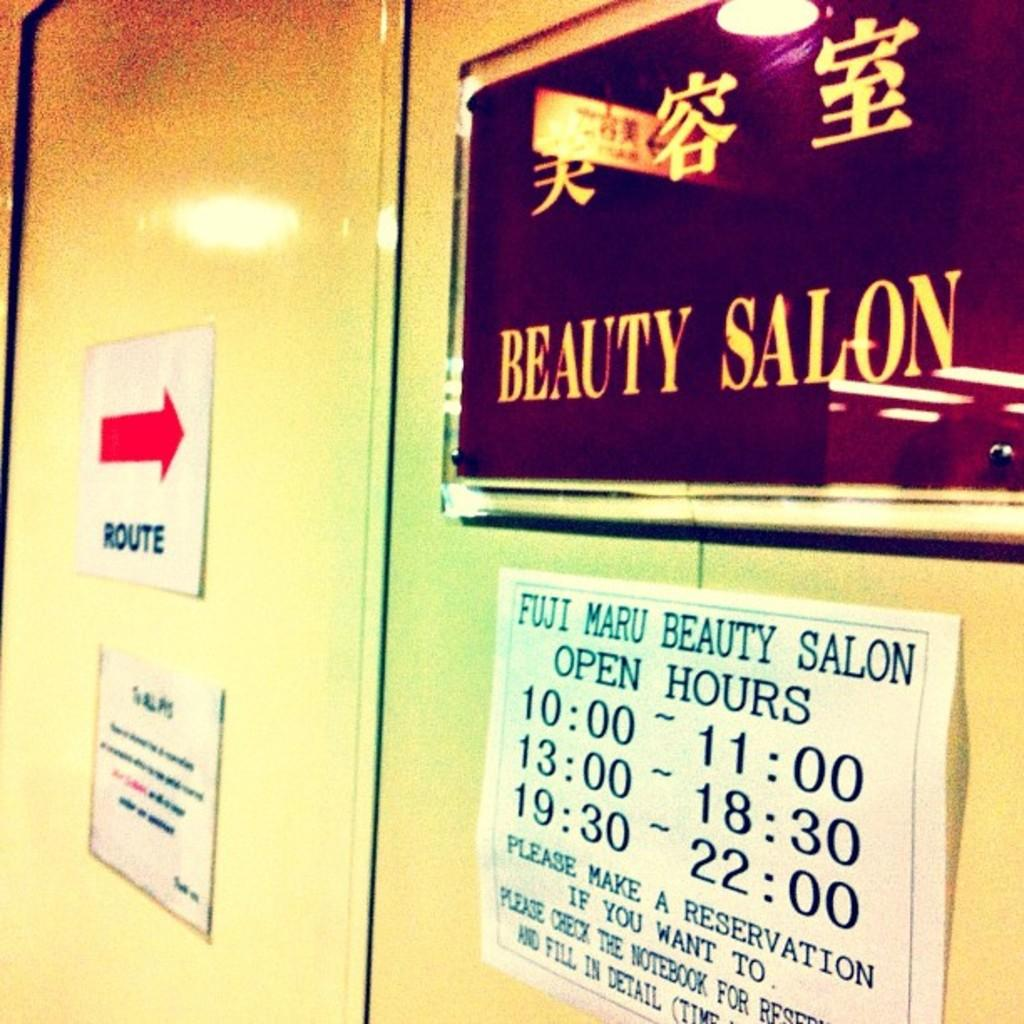Provide a one-sentence caption for the provided image. Sign for a beauty salon saying that they are open at 10. 